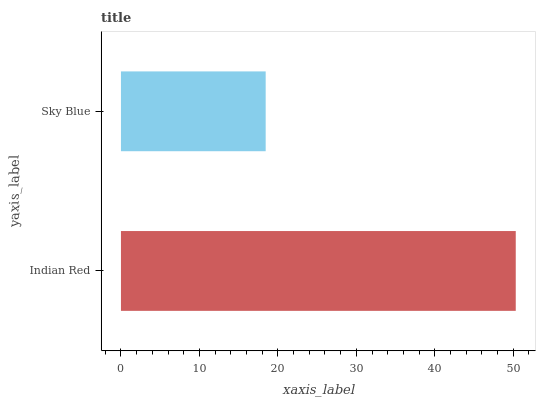Is Sky Blue the minimum?
Answer yes or no. Yes. Is Indian Red the maximum?
Answer yes or no. Yes. Is Sky Blue the maximum?
Answer yes or no. No. Is Indian Red greater than Sky Blue?
Answer yes or no. Yes. Is Sky Blue less than Indian Red?
Answer yes or no. Yes. Is Sky Blue greater than Indian Red?
Answer yes or no. No. Is Indian Red less than Sky Blue?
Answer yes or no. No. Is Indian Red the high median?
Answer yes or no. Yes. Is Sky Blue the low median?
Answer yes or no. Yes. Is Sky Blue the high median?
Answer yes or no. No. Is Indian Red the low median?
Answer yes or no. No. 